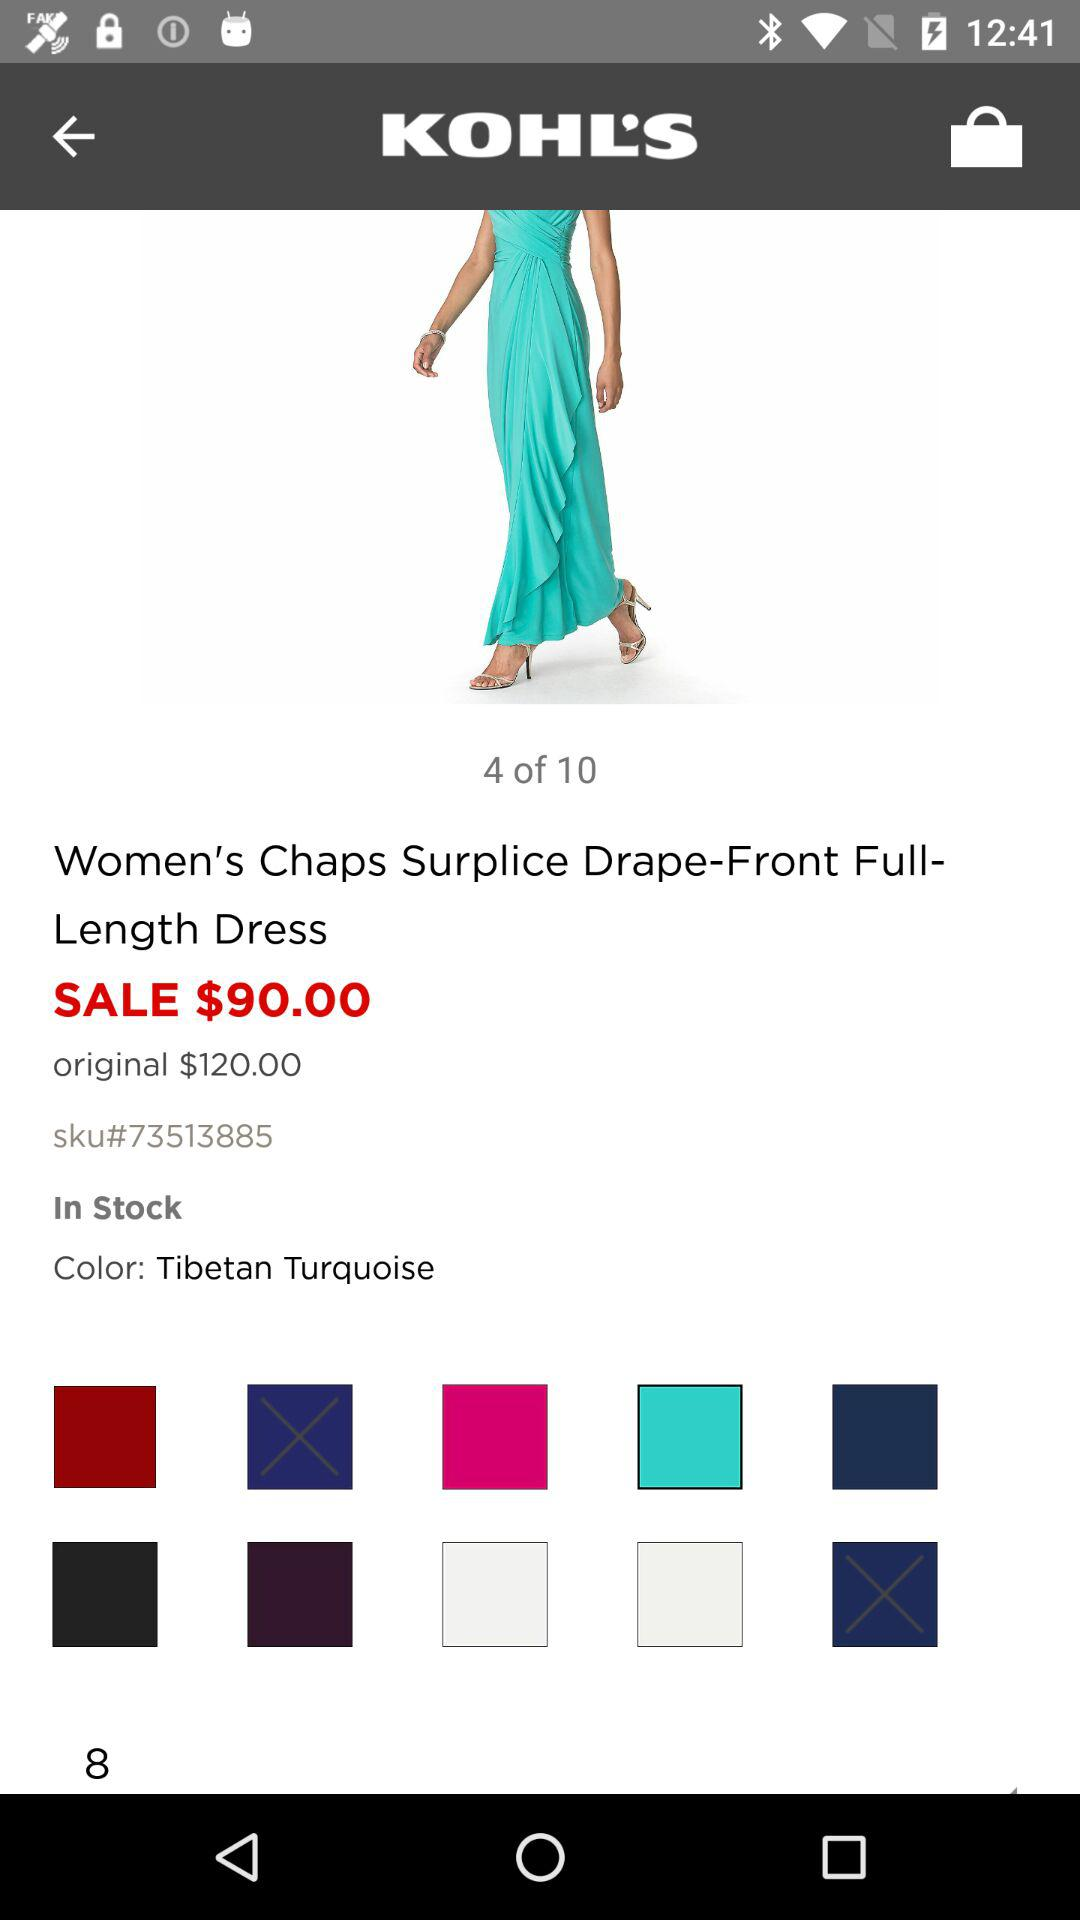What is the original price of the dress? The original price of the dress is $120.00. 